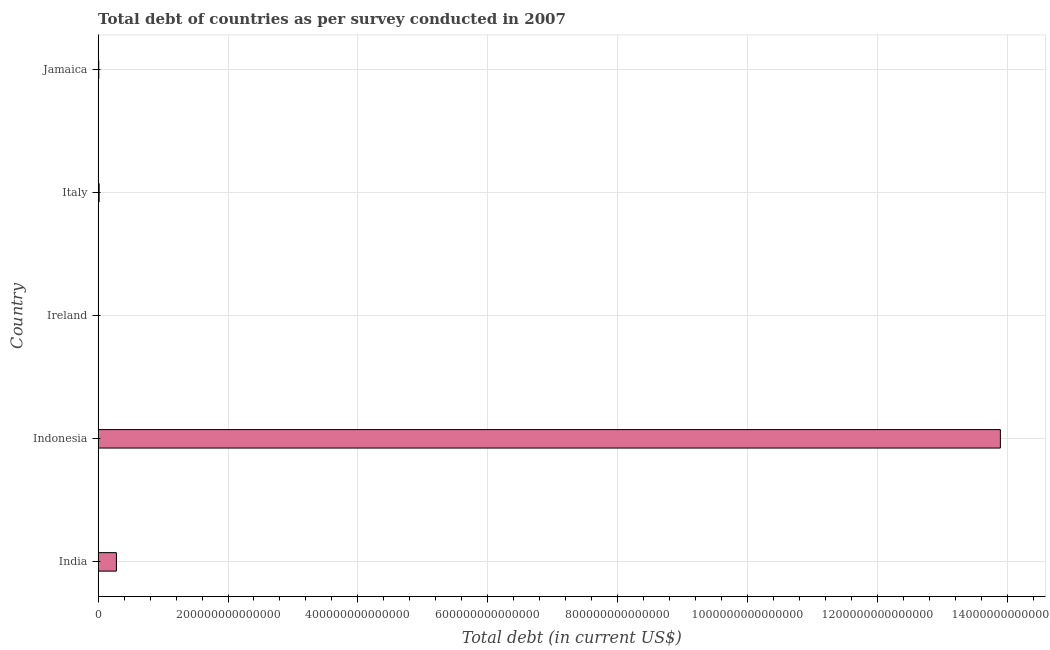Does the graph contain grids?
Your answer should be very brief. Yes. What is the title of the graph?
Your response must be concise. Total debt of countries as per survey conducted in 2007. What is the label or title of the X-axis?
Make the answer very short. Total debt (in current US$). What is the label or title of the Y-axis?
Offer a terse response. Country. What is the total debt in Ireland?
Give a very brief answer. 5.44e+1. Across all countries, what is the maximum total debt?
Provide a short and direct response. 1.39e+15. Across all countries, what is the minimum total debt?
Make the answer very short. 5.44e+1. In which country was the total debt maximum?
Keep it short and to the point. Indonesia. In which country was the total debt minimum?
Offer a terse response. Ireland. What is the sum of the total debt?
Provide a short and direct response. 1.42e+15. What is the difference between the total debt in Ireland and Jamaica?
Give a very brief answer. -9.46e+11. What is the average total debt per country?
Your answer should be very brief. 2.84e+14. What is the median total debt?
Ensure brevity in your answer.  1.62e+12. In how many countries, is the total debt greater than 1360000000000000 US$?
Make the answer very short. 1. What is the ratio of the total debt in India to that in Jamaica?
Make the answer very short. 28.15. Is the difference between the total debt in India and Indonesia greater than the difference between any two countries?
Your answer should be very brief. No. What is the difference between the highest and the second highest total debt?
Keep it short and to the point. 1.36e+15. What is the difference between the highest and the lowest total debt?
Keep it short and to the point. 1.39e+15. In how many countries, is the total debt greater than the average total debt taken over all countries?
Your answer should be compact. 1. Are all the bars in the graph horizontal?
Your answer should be compact. Yes. How many countries are there in the graph?
Make the answer very short. 5. What is the difference between two consecutive major ticks on the X-axis?
Provide a short and direct response. 2.00e+14. What is the Total debt (in current US$) of India?
Make the answer very short. 2.82e+13. What is the Total debt (in current US$) of Indonesia?
Keep it short and to the point. 1.39e+15. What is the Total debt (in current US$) of Ireland?
Provide a succinct answer. 5.44e+1. What is the Total debt (in current US$) in Italy?
Your answer should be very brief. 1.62e+12. What is the Total debt (in current US$) in Jamaica?
Provide a succinct answer. 1.00e+12. What is the difference between the Total debt (in current US$) in India and Indonesia?
Your answer should be very brief. -1.36e+15. What is the difference between the Total debt (in current US$) in India and Ireland?
Make the answer very short. 2.81e+13. What is the difference between the Total debt (in current US$) in India and Italy?
Give a very brief answer. 2.65e+13. What is the difference between the Total debt (in current US$) in India and Jamaica?
Give a very brief answer. 2.72e+13. What is the difference between the Total debt (in current US$) in Indonesia and Ireland?
Make the answer very short. 1.39e+15. What is the difference between the Total debt (in current US$) in Indonesia and Italy?
Your response must be concise. 1.39e+15. What is the difference between the Total debt (in current US$) in Indonesia and Jamaica?
Keep it short and to the point. 1.39e+15. What is the difference between the Total debt (in current US$) in Ireland and Italy?
Make the answer very short. -1.57e+12. What is the difference between the Total debt (in current US$) in Ireland and Jamaica?
Provide a short and direct response. -9.46e+11. What is the difference between the Total debt (in current US$) in Italy and Jamaica?
Give a very brief answer. 6.20e+11. What is the ratio of the Total debt (in current US$) in India to that in Ireland?
Offer a terse response. 518.05. What is the ratio of the Total debt (in current US$) in India to that in Italy?
Your answer should be compact. 17.38. What is the ratio of the Total debt (in current US$) in India to that in Jamaica?
Your answer should be very brief. 28.15. What is the ratio of the Total debt (in current US$) in Indonesia to that in Ireland?
Offer a very short reply. 2.56e+04. What is the ratio of the Total debt (in current US$) in Indonesia to that in Italy?
Make the answer very short. 857.52. What is the ratio of the Total debt (in current US$) in Indonesia to that in Jamaica?
Your answer should be very brief. 1388.47. What is the ratio of the Total debt (in current US$) in Ireland to that in Italy?
Ensure brevity in your answer.  0.03. What is the ratio of the Total debt (in current US$) in Ireland to that in Jamaica?
Your response must be concise. 0.05. What is the ratio of the Total debt (in current US$) in Italy to that in Jamaica?
Your answer should be very brief. 1.62. 